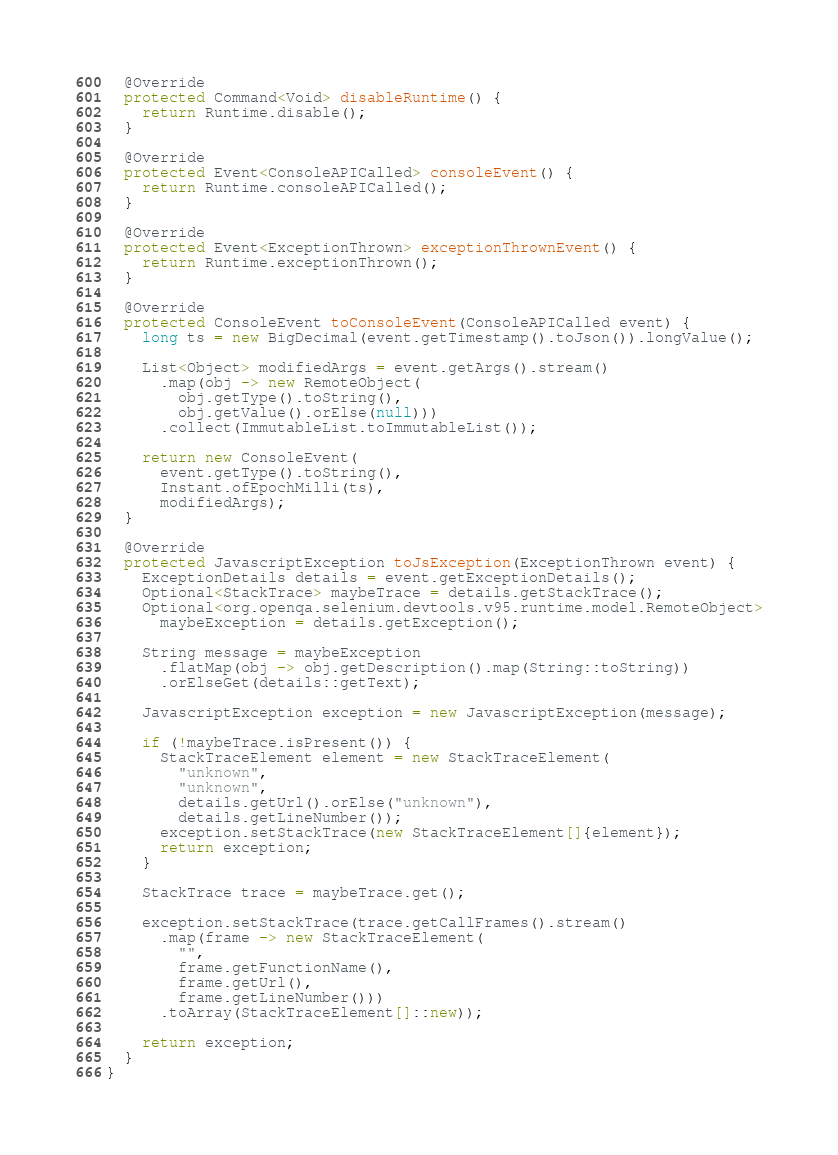Convert code to text. <code><loc_0><loc_0><loc_500><loc_500><_Java_>  @Override
  protected Command<Void> disableRuntime() {
    return Runtime.disable();
  }

  @Override
  protected Event<ConsoleAPICalled> consoleEvent() {
    return Runtime.consoleAPICalled();
  }

  @Override
  protected Event<ExceptionThrown> exceptionThrownEvent() {
    return Runtime.exceptionThrown();
  }

  @Override
  protected ConsoleEvent toConsoleEvent(ConsoleAPICalled event) {
    long ts = new BigDecimal(event.getTimestamp().toJson()).longValue();

    List<Object> modifiedArgs = event.getArgs().stream()
      .map(obj -> new RemoteObject(
        obj.getType().toString(),
        obj.getValue().orElse(null)))
      .collect(ImmutableList.toImmutableList());

    return new ConsoleEvent(
      event.getType().toString(),
      Instant.ofEpochMilli(ts),
      modifiedArgs);
  }

  @Override
  protected JavascriptException toJsException(ExceptionThrown event) {
    ExceptionDetails details = event.getExceptionDetails();
    Optional<StackTrace> maybeTrace = details.getStackTrace();
    Optional<org.openqa.selenium.devtools.v95.runtime.model.RemoteObject>
      maybeException = details.getException();

    String message = maybeException
      .flatMap(obj -> obj.getDescription().map(String::toString))
      .orElseGet(details::getText);

    JavascriptException exception = new JavascriptException(message);

    if (!maybeTrace.isPresent()) {
      StackTraceElement element = new StackTraceElement(
        "unknown",
        "unknown",
        details.getUrl().orElse("unknown"),
        details.getLineNumber());
      exception.setStackTrace(new StackTraceElement[]{element});
      return exception;
    }

    StackTrace trace = maybeTrace.get();

    exception.setStackTrace(trace.getCallFrames().stream()
      .map(frame -> new StackTraceElement(
        "",
        frame.getFunctionName(),
        frame.getUrl(),
        frame.getLineNumber()))
      .toArray(StackTraceElement[]::new));

    return exception;
  }
}
</code> 